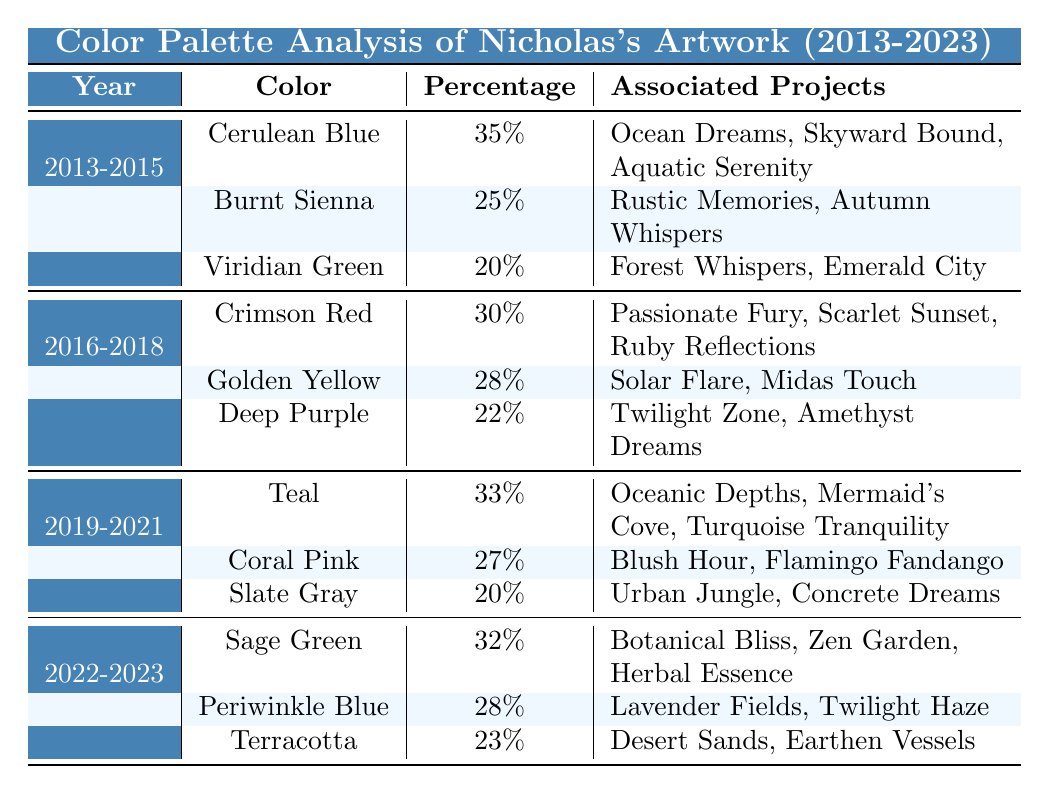What are the dominant colors in 2019-2021? In the table, the dominant colors for the period from 2019 to 2021 are Teal, Coral Pink, and Slate Gray.
Answer: Teal, Coral Pink, Slate Gray Which year had the highest percentage of Dominant Colors? The year with the highest percentage of a dominant color is 2013-2015, where Cerulean Blue is at 35%.
Answer: 2013-2015 Is Golden Yellow associated with the project "Midas Touch"? Yes, Golden Yellow is listed as a dominant color for the projects, including "Midas Touch."
Answer: Yes What is the sum of the percentages of the dominant colors from 2016-2018? For 2016-2018, the percentages of the dominant colors are 30% (Crimson Red) + 28% (Golden Yellow) + 22% (Deep Purple), which totals 80%.
Answer: 80% What is the average percentage of dominant colors in the period 2022-2023? The dominant colors for 2022-2023 have the percentages: 32% (Sage Green), 28% (Periwinkle Blue), and 23% (Terracotta). The sum is 83%, and since there are three colors, the average is 83/3 = 27.67%.
Answer: 27.67% Which two colors appeared most frequently in projects across the entire table? After examining the associated projects, Cerulean Blue (appeared in 3 projects from 2013-2015) and Teal (also appeared in 3 projects from 2019-2021) both have the highest frequency.
Answer: Cerulean Blue and Teal Which project was associated with the most recent dominant color? The most recent dominant color listed is Sage Green (2022-2023), which is associated with the projects "Botanical Bliss," "Zen Garden," and "Herbal Essence."
Answer: Botanical Bliss, Zen Garden, Herbal Essence Did the use of shades of blue increase, decrease, or remain stable from the period 2013-2015 to 2022-2023? In the first period, Cerulean Blue was at 35% and in the most recent one, Sage Green was at 32% with Periwinkle Blue at 28%, indicating a decline in the use of blue shades.
Answer: Decrease Which dominant color has the lowest percentage across all the years analyzed? The lowest percentage across all years is 20% associated with Viridian Green (2013-2015) and Slate Gray (2019-2021).
Answer: Viridian Green, Slate Gray How many distinct colors were used in Nicholas's artwork from 2013-2023? By counting the different colors listed in each period (3 colors for each of the four periods), there are a total of 12 distinct colors.
Answer: 12 